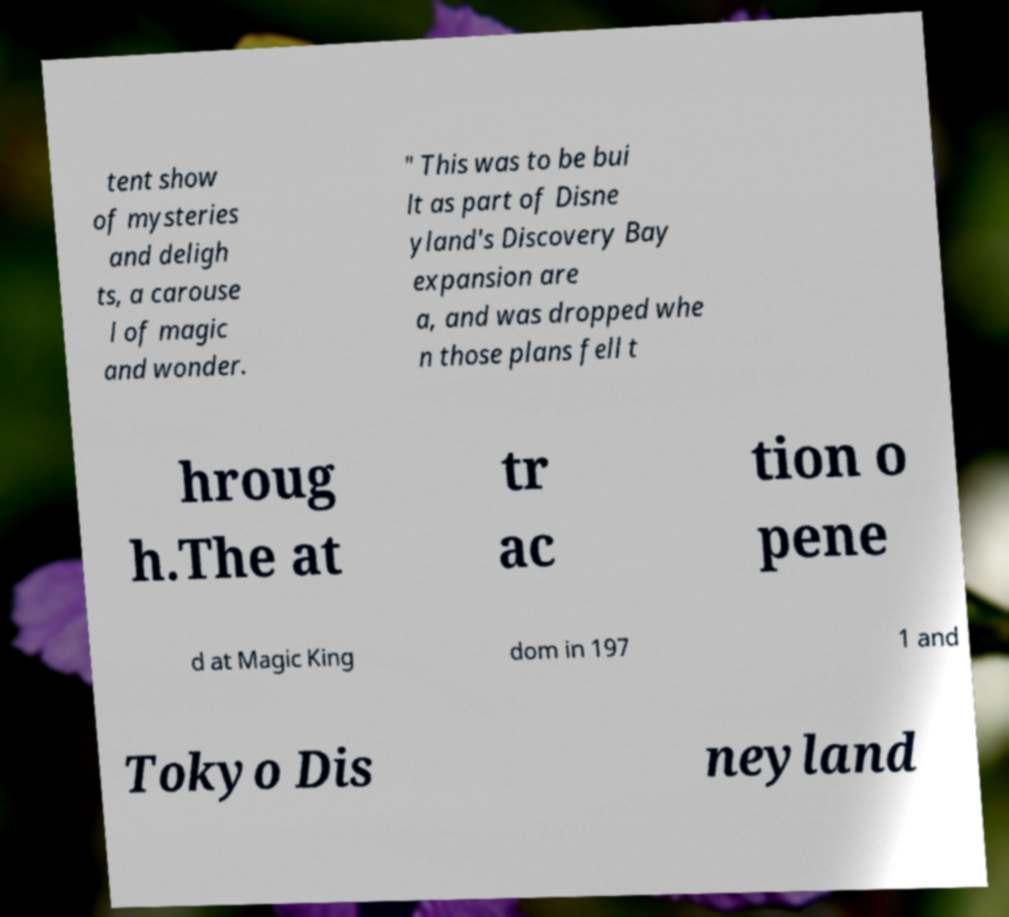Please identify and transcribe the text found in this image. tent show of mysteries and deligh ts, a carouse l of magic and wonder. " This was to be bui lt as part of Disne yland's Discovery Bay expansion are a, and was dropped whe n those plans fell t hroug h.The at tr ac tion o pene d at Magic King dom in 197 1 and Tokyo Dis neyland 